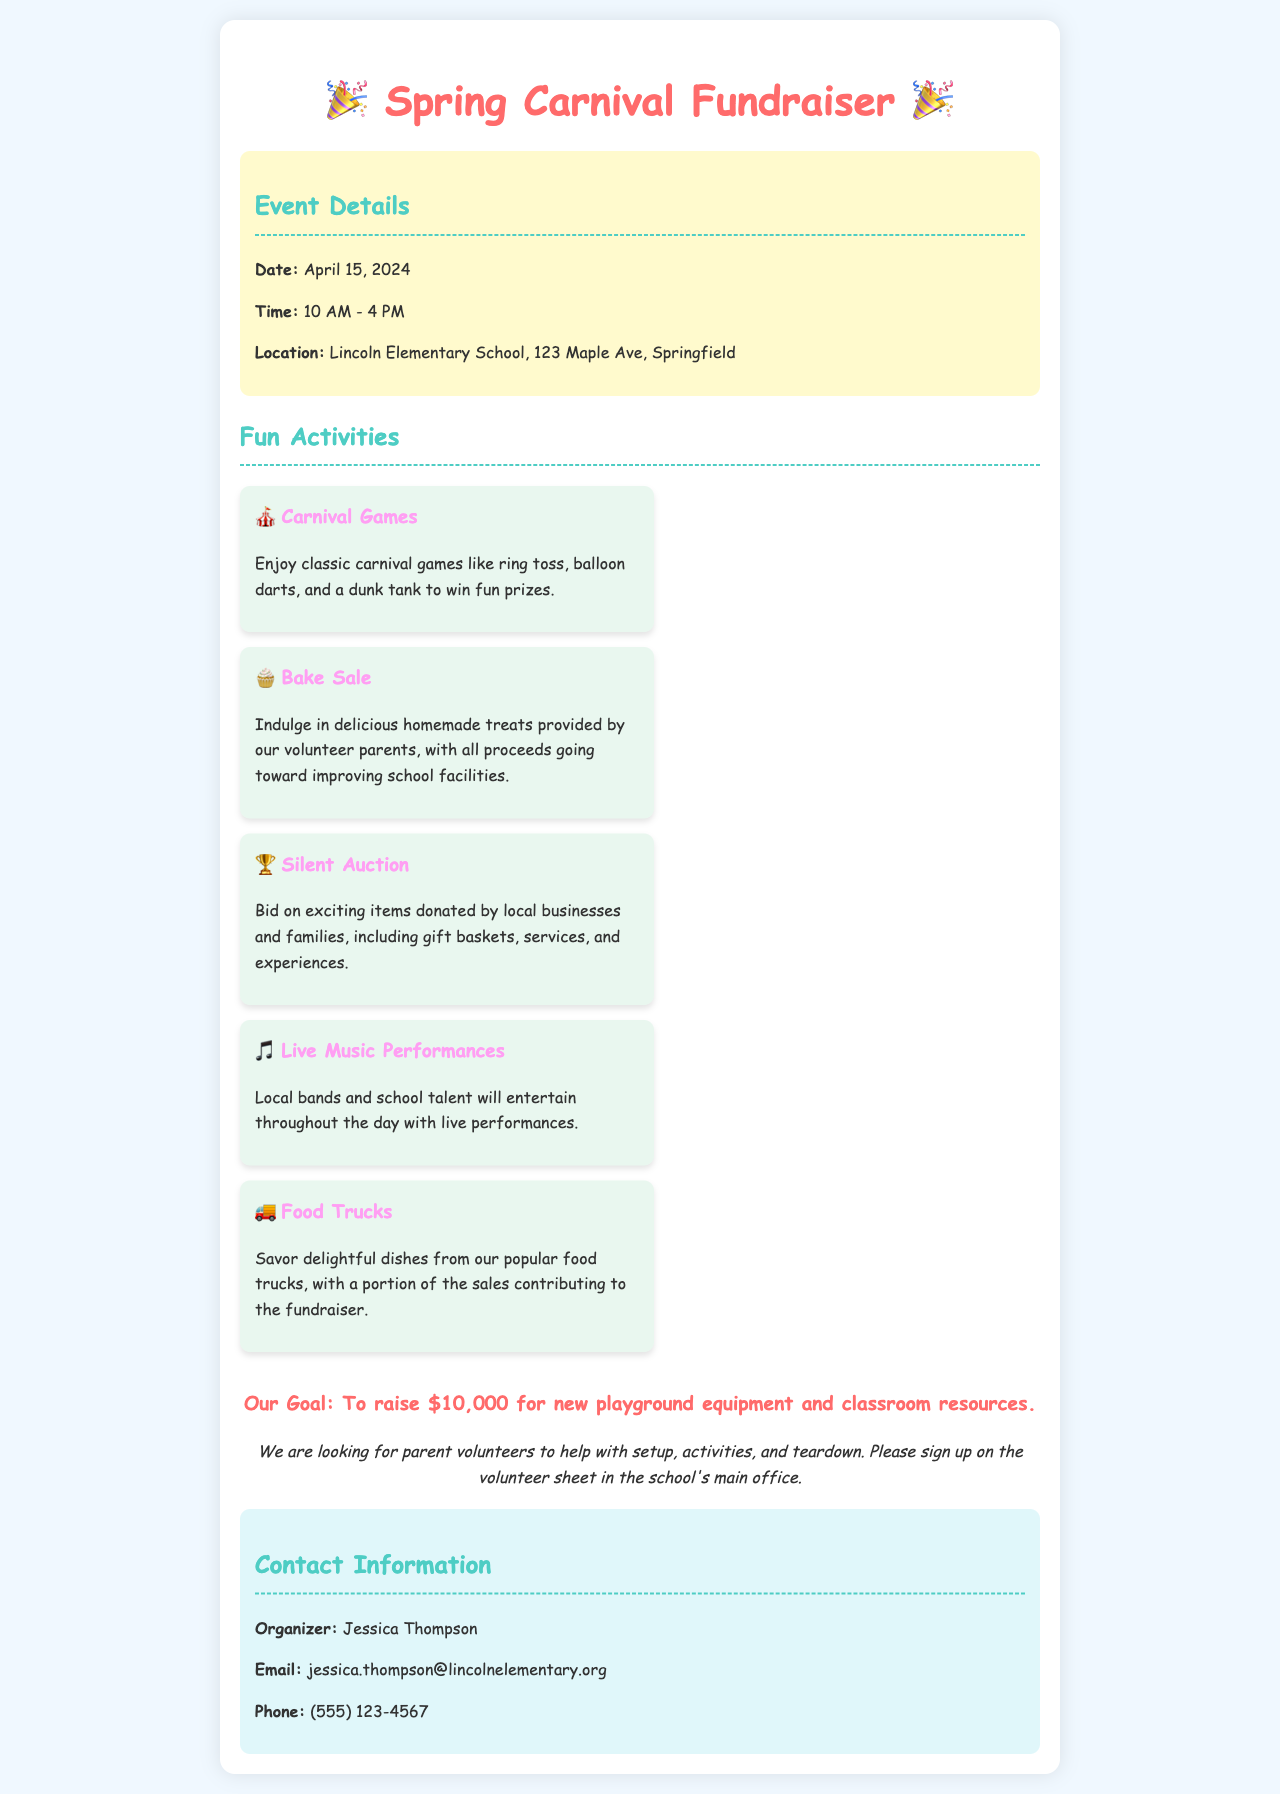What is the date of the event? The date of the event is explicitly stated in the document details.
Answer: April 15, 2024 What time does the event start? The start time for the event is clearly mentioned in the event details section.
Answer: 10 AM Where is the Spring Carnival Fundraiser being held? The location of the event is provided under the event details.
Answer: Lincoln Elementary School, 123 Maple Ave, Springfield What is the fundraising goal? The goal for the fundraiser is stated in the goal section of the document.
Answer: $10,000 Which activity involves food trucks? The activity mentioned that includes food trucks is labeled in the activities section.
Answer: Food Trucks What type of auction will take place? The type of auction mentioned in the document is listed in the activities section.
Answer: Silent Auction Which group of individuals is needed for assistance? The document specifies a group that is required for help in the volunteers section.
Answer: Parent volunteers What is being sold at the bake sale? The bake sale details what items will be available for sale as per the activities.
Answer: Homemade treats 